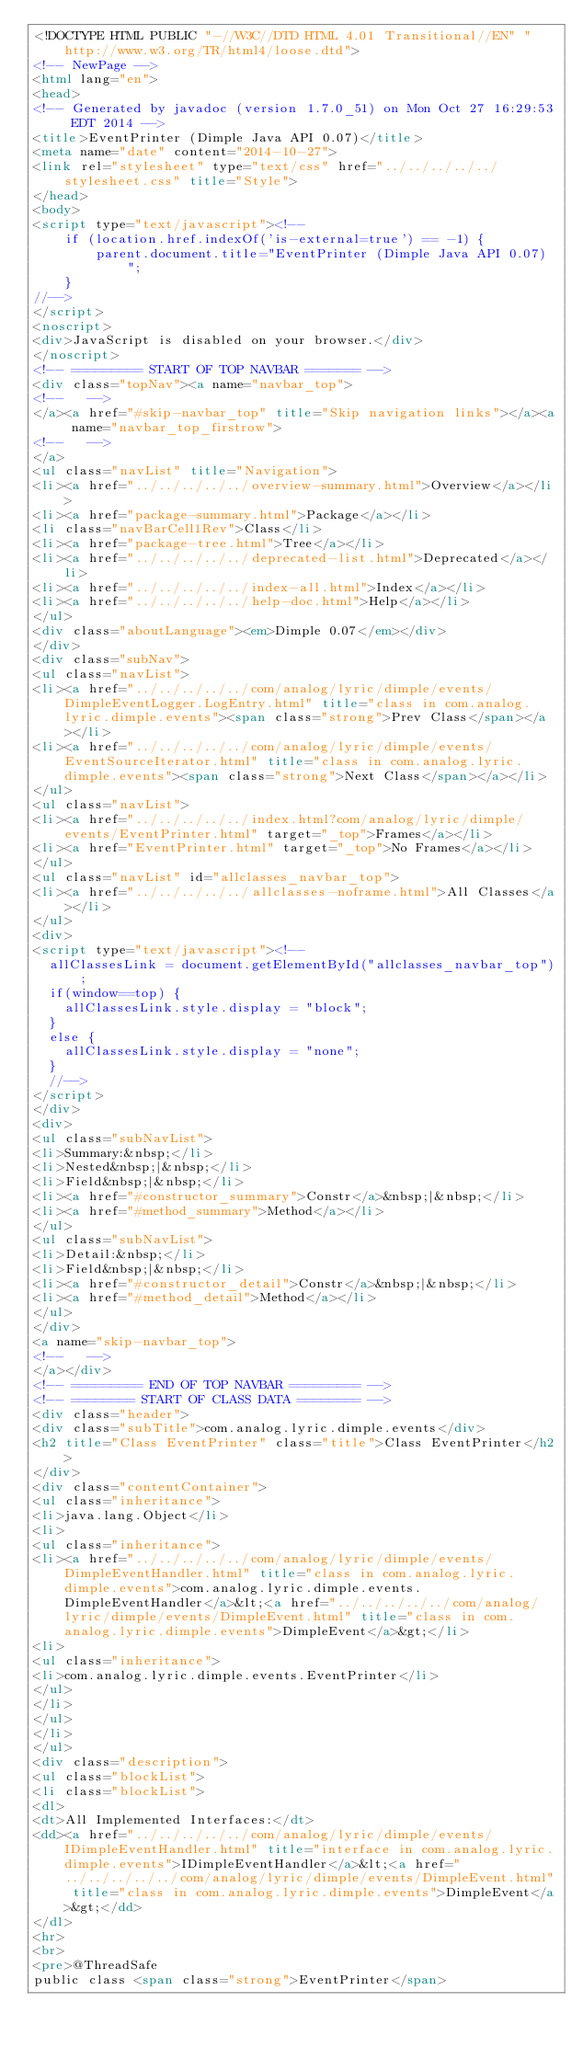Convert code to text. <code><loc_0><loc_0><loc_500><loc_500><_HTML_><!DOCTYPE HTML PUBLIC "-//W3C//DTD HTML 4.01 Transitional//EN" "http://www.w3.org/TR/html4/loose.dtd">
<!-- NewPage -->
<html lang="en">
<head>
<!-- Generated by javadoc (version 1.7.0_51) on Mon Oct 27 16:29:53 EDT 2014 -->
<title>EventPrinter (Dimple Java API 0.07)</title>
<meta name="date" content="2014-10-27">
<link rel="stylesheet" type="text/css" href="../../../../../stylesheet.css" title="Style">
</head>
<body>
<script type="text/javascript"><!--
    if (location.href.indexOf('is-external=true') == -1) {
        parent.document.title="EventPrinter (Dimple Java API 0.07)";
    }
//-->
</script>
<noscript>
<div>JavaScript is disabled on your browser.</div>
</noscript>
<!-- ========= START OF TOP NAVBAR ======= -->
<div class="topNav"><a name="navbar_top">
<!--   -->
</a><a href="#skip-navbar_top" title="Skip navigation links"></a><a name="navbar_top_firstrow">
<!--   -->
</a>
<ul class="navList" title="Navigation">
<li><a href="../../../../../overview-summary.html">Overview</a></li>
<li><a href="package-summary.html">Package</a></li>
<li class="navBarCell1Rev">Class</li>
<li><a href="package-tree.html">Tree</a></li>
<li><a href="../../../../../deprecated-list.html">Deprecated</a></li>
<li><a href="../../../../../index-all.html">Index</a></li>
<li><a href="../../../../../help-doc.html">Help</a></li>
</ul>
<div class="aboutLanguage"><em>Dimple 0.07</em></div>
</div>
<div class="subNav">
<ul class="navList">
<li><a href="../../../../../com/analog/lyric/dimple/events/DimpleEventLogger.LogEntry.html" title="class in com.analog.lyric.dimple.events"><span class="strong">Prev Class</span></a></li>
<li><a href="../../../../../com/analog/lyric/dimple/events/EventSourceIterator.html" title="class in com.analog.lyric.dimple.events"><span class="strong">Next Class</span></a></li>
</ul>
<ul class="navList">
<li><a href="../../../../../index.html?com/analog/lyric/dimple/events/EventPrinter.html" target="_top">Frames</a></li>
<li><a href="EventPrinter.html" target="_top">No Frames</a></li>
</ul>
<ul class="navList" id="allclasses_navbar_top">
<li><a href="../../../../../allclasses-noframe.html">All Classes</a></li>
</ul>
<div>
<script type="text/javascript"><!--
  allClassesLink = document.getElementById("allclasses_navbar_top");
  if(window==top) {
    allClassesLink.style.display = "block";
  }
  else {
    allClassesLink.style.display = "none";
  }
  //-->
</script>
</div>
<div>
<ul class="subNavList">
<li>Summary:&nbsp;</li>
<li>Nested&nbsp;|&nbsp;</li>
<li>Field&nbsp;|&nbsp;</li>
<li><a href="#constructor_summary">Constr</a>&nbsp;|&nbsp;</li>
<li><a href="#method_summary">Method</a></li>
</ul>
<ul class="subNavList">
<li>Detail:&nbsp;</li>
<li>Field&nbsp;|&nbsp;</li>
<li><a href="#constructor_detail">Constr</a>&nbsp;|&nbsp;</li>
<li><a href="#method_detail">Method</a></li>
</ul>
</div>
<a name="skip-navbar_top">
<!--   -->
</a></div>
<!-- ========= END OF TOP NAVBAR ========= -->
<!-- ======== START OF CLASS DATA ======== -->
<div class="header">
<div class="subTitle">com.analog.lyric.dimple.events</div>
<h2 title="Class EventPrinter" class="title">Class EventPrinter</h2>
</div>
<div class="contentContainer">
<ul class="inheritance">
<li>java.lang.Object</li>
<li>
<ul class="inheritance">
<li><a href="../../../../../com/analog/lyric/dimple/events/DimpleEventHandler.html" title="class in com.analog.lyric.dimple.events">com.analog.lyric.dimple.events.DimpleEventHandler</a>&lt;<a href="../../../../../com/analog/lyric/dimple/events/DimpleEvent.html" title="class in com.analog.lyric.dimple.events">DimpleEvent</a>&gt;</li>
<li>
<ul class="inheritance">
<li>com.analog.lyric.dimple.events.EventPrinter</li>
</ul>
</li>
</ul>
</li>
</ul>
<div class="description">
<ul class="blockList">
<li class="blockList">
<dl>
<dt>All Implemented Interfaces:</dt>
<dd><a href="../../../../../com/analog/lyric/dimple/events/IDimpleEventHandler.html" title="interface in com.analog.lyric.dimple.events">IDimpleEventHandler</a>&lt;<a href="../../../../../com/analog/lyric/dimple/events/DimpleEvent.html" title="class in com.analog.lyric.dimple.events">DimpleEvent</a>&gt;</dd>
</dl>
<hr>
<br>
<pre>@ThreadSafe
public class <span class="strong">EventPrinter</span></code> 